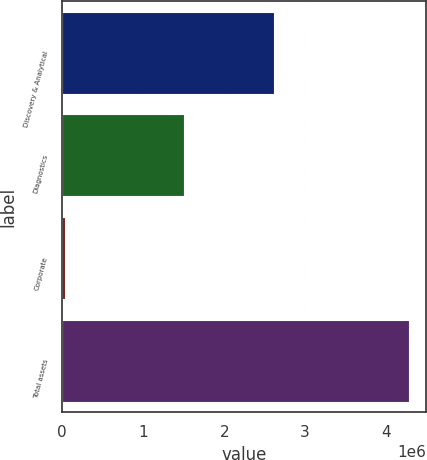Convert chart. <chart><loc_0><loc_0><loc_500><loc_500><bar_chart><fcel>Discovery & Analytical<fcel>Diagnostics<fcel>Corporate<fcel>Total assets<nl><fcel>2.61276e+06<fcel>1.50538e+06<fcel>31171<fcel>4.27668e+06<nl></chart> 